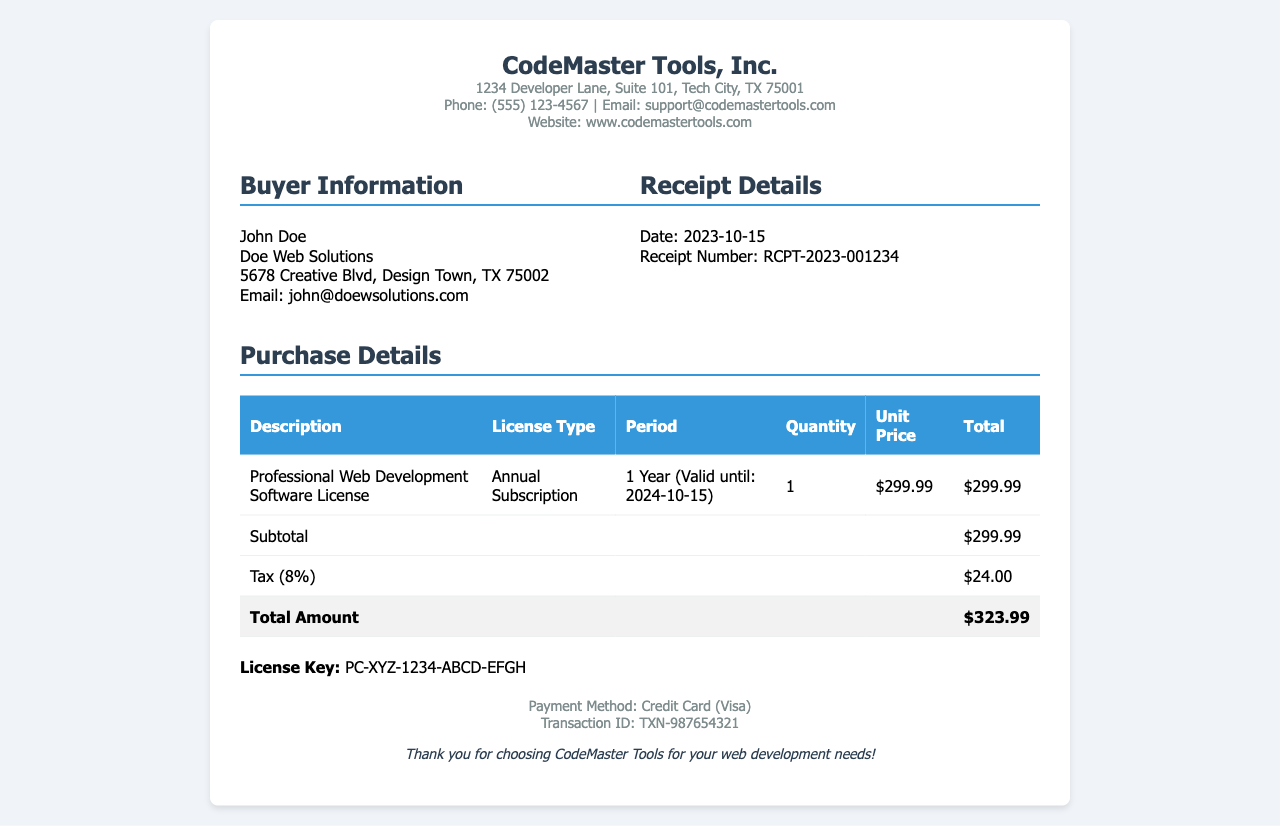What is the name of the company that issued the receipt? The company indicated at the top of the receipt is the one that issued the document, which is CodeMaster Tools, Inc.
Answer: CodeMaster Tools, Inc What is the total amount due on the receipt? The total amount is the final figure shown on the receipt, which includes the subtotal and tax.
Answer: $323.99 When is the license valid until? The validity of the purchased license is stated in the purchase details section along with the period.
Answer: 2024-10-15 What method of payment was used for the purchase? The method used for payment is also detailed in the payment section of the receipt.
Answer: Credit Card (Visa) What is the receipt number? The receipt number is a unique identifier provided in the receipt details section.
Answer: RCPT-2023-001234 What is the subtotal before tax? The subtotal is the total price of items before tax is added, as listed in the table.
Answer: $299.99 How much tax was applied to the purchase? The receipt specifies a singular tax amount, clearly mentioned in the summary table.
Answer: $24.00 Who is the buyer? The buyer information section lists the name and business of the purchaser of the license.
Answer: John Doe What is the license type purchased? The type of the license is categorized under the purchase details in the table format.
Answer: Annual Subscription 